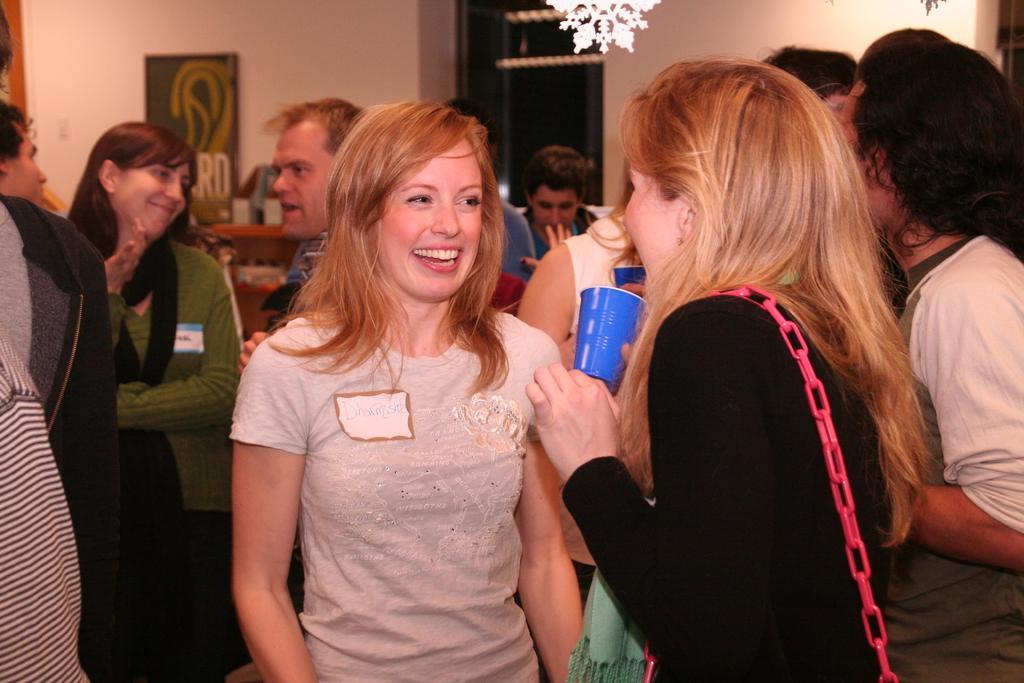Can you describe this image briefly? In this picture there are people in the center of the image and there are windows on the right side of the image, there is a rack on the left side of the image and there is light at the top side of the image. 